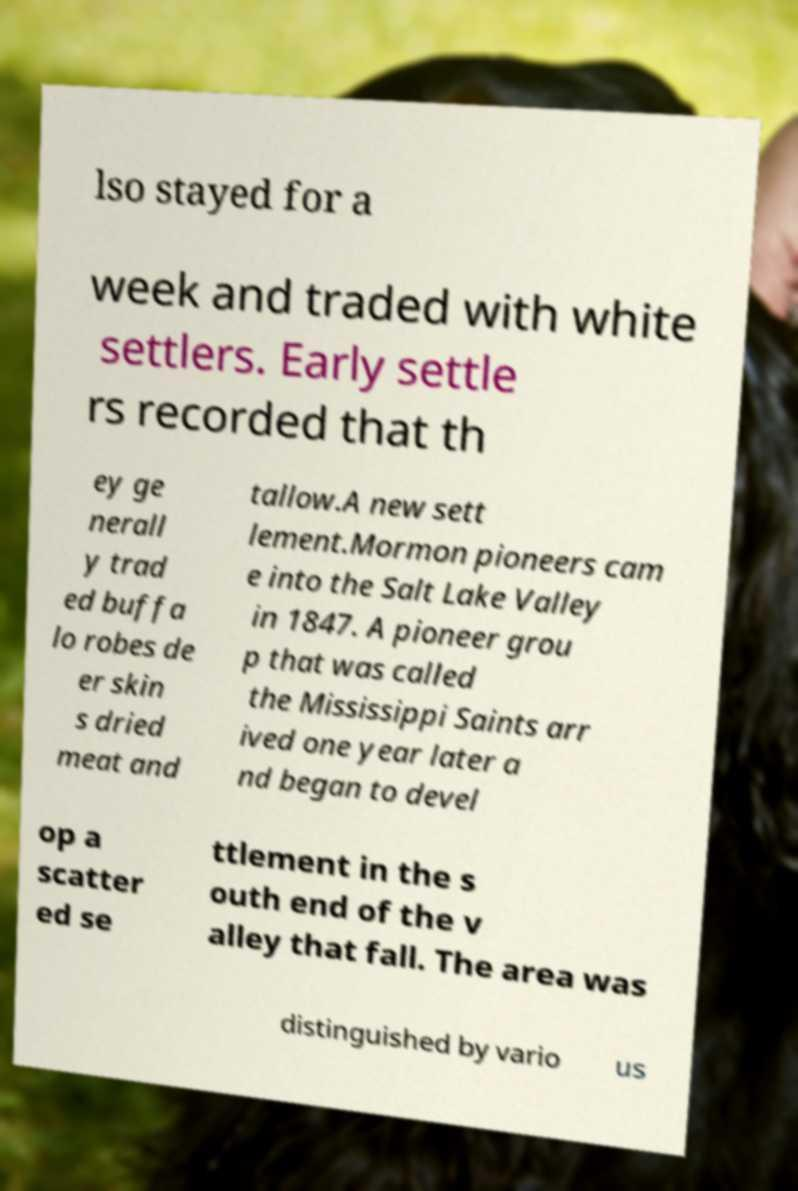Please identify and transcribe the text found in this image. lso stayed for a week and traded with white settlers. Early settle rs recorded that th ey ge nerall y trad ed buffa lo robes de er skin s dried meat and tallow.A new sett lement.Mormon pioneers cam e into the Salt Lake Valley in 1847. A pioneer grou p that was called the Mississippi Saints arr ived one year later a nd began to devel op a scatter ed se ttlement in the s outh end of the v alley that fall. The area was distinguished by vario us 